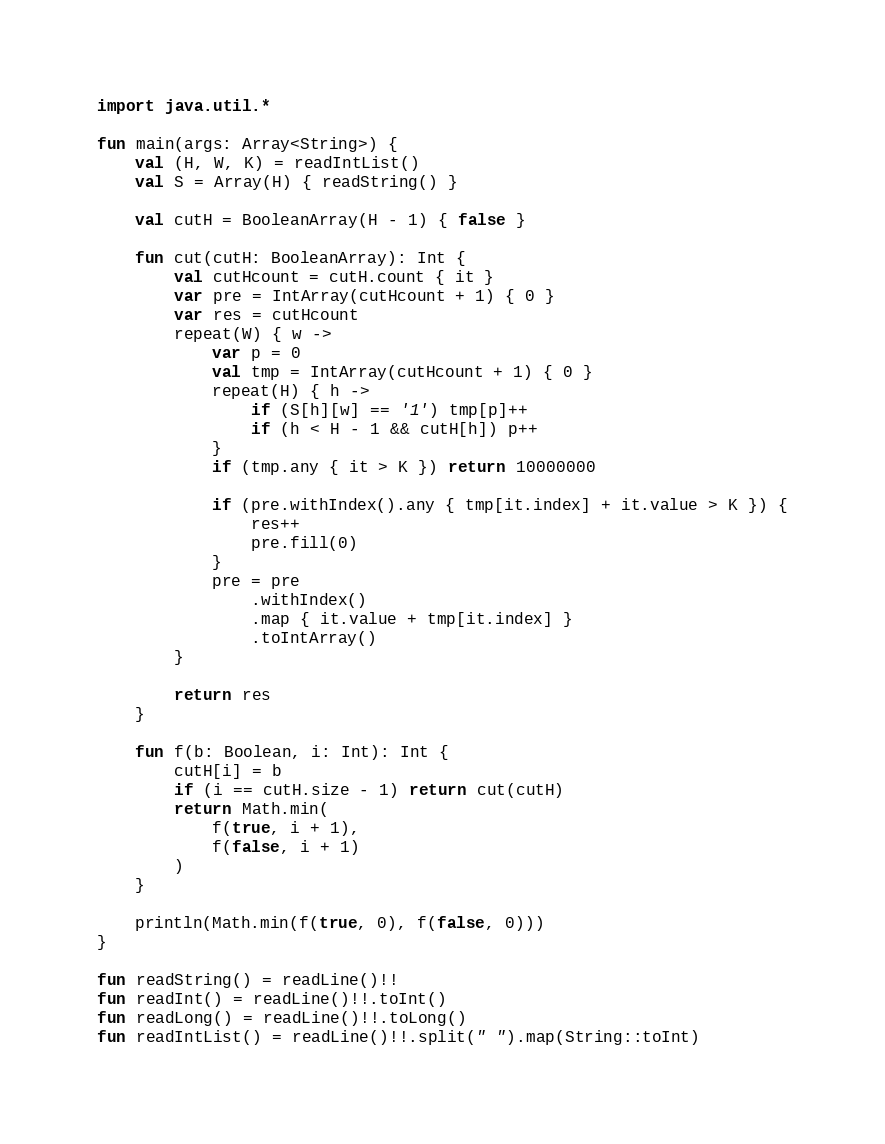Convert code to text. <code><loc_0><loc_0><loc_500><loc_500><_Kotlin_>import java.util.*

fun main(args: Array<String>) {
    val (H, W, K) = readIntList()
    val S = Array(H) { readString() }

    val cutH = BooleanArray(H - 1) { false }

    fun cut(cutH: BooleanArray): Int {
        val cutHcount = cutH.count { it }
        var pre = IntArray(cutHcount + 1) { 0 }
        var res = cutHcount
        repeat(W) { w ->
            var p = 0
            val tmp = IntArray(cutHcount + 1) { 0 }
            repeat(H) { h ->
                if (S[h][w] == '1') tmp[p]++
                if (h < H - 1 && cutH[h]) p++
            }
            if (tmp.any { it > K }) return 10000000

            if (pre.withIndex().any { tmp[it.index] + it.value > K }) {
                res++
                pre.fill(0)
            }
            pre = pre
                .withIndex()
                .map { it.value + tmp[it.index] }
                .toIntArray()
        }

        return res
    }

    fun f(b: Boolean, i: Int): Int {
        cutH[i] = b
        if (i == cutH.size - 1) return cut(cutH)
        return Math.min(
            f(true, i + 1),
            f(false, i + 1)
        )
    }

    println(Math.min(f(true, 0), f(false, 0)))
}

fun readString() = readLine()!!
fun readInt() = readLine()!!.toInt()
fun readLong() = readLine()!!.toLong()
fun readIntList() = readLine()!!.split(" ").map(String::toInt)</code> 